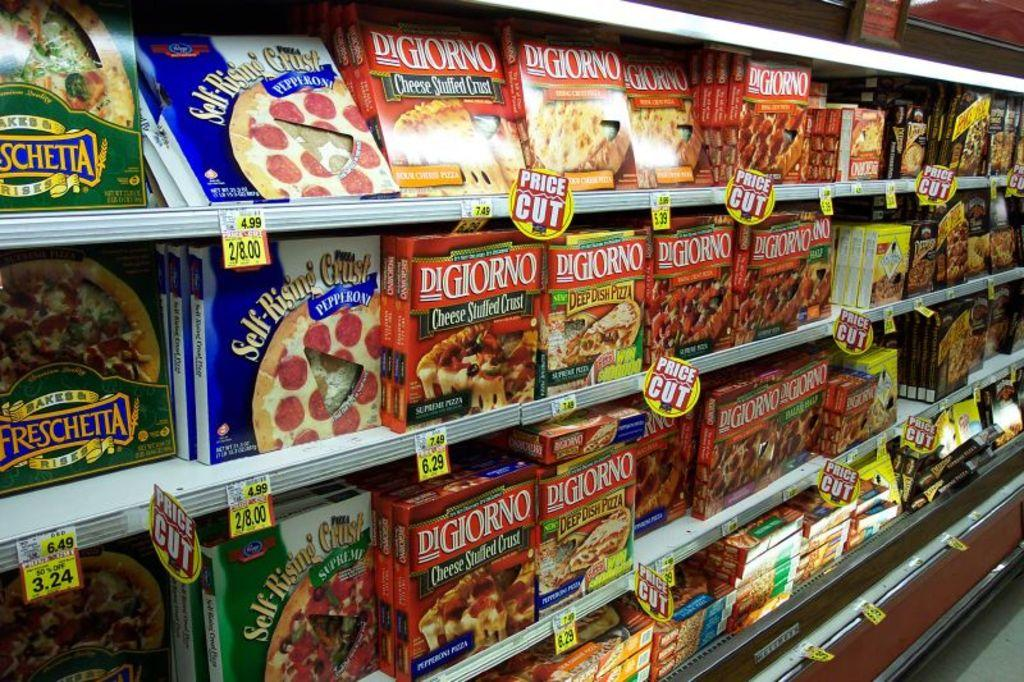Provide a one-sentence caption for the provided image. The pizza section of this grocery market is loaded with tons of options like Freschetts, Digiornos, and many others. 